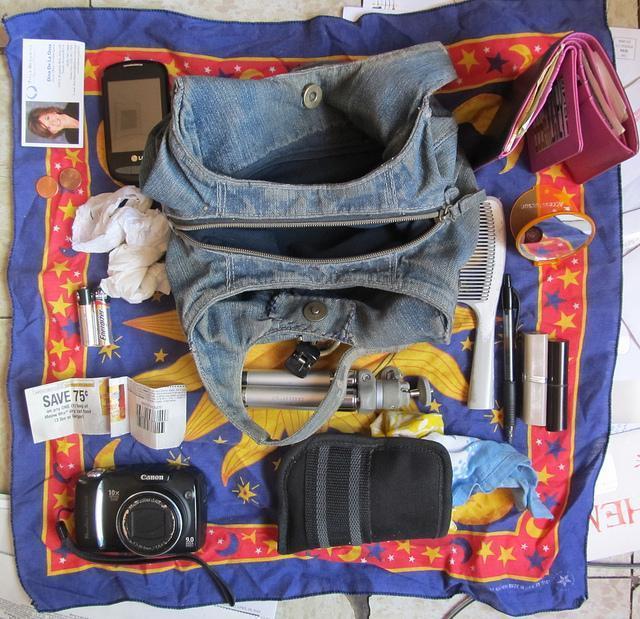How many people are there?
Give a very brief answer. 0. 